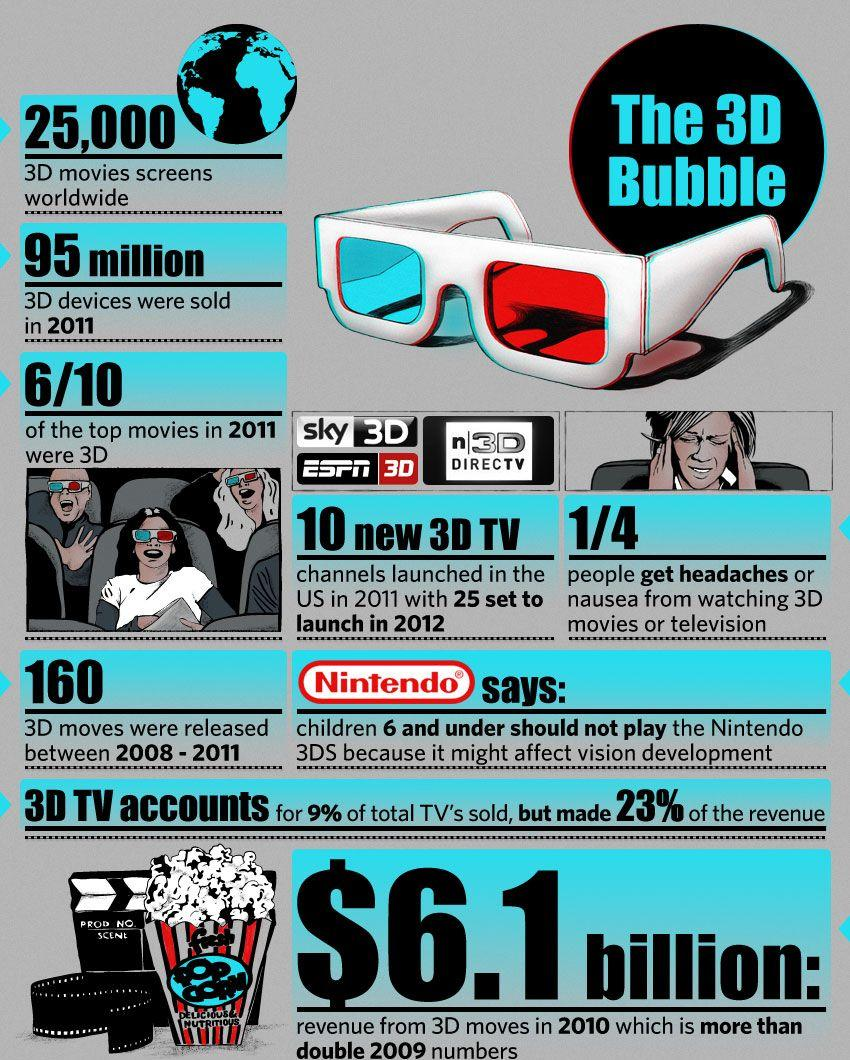Identify some key points in this picture. According to our data, 3D TV accounts for approximately 23% of our total revenue. In 2010, the revenue generated from 3D movies was $6.1 billion. In 2011, a total of 95 million 3D devices were sold. In 2011, out of the top 10 movies that were launched, 6 of them were in 3D format. Between 2008 and 2011, there were 160 releases of 3D movies. 